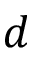Convert formula to latex. <formula><loc_0><loc_0><loc_500><loc_500>d</formula> 